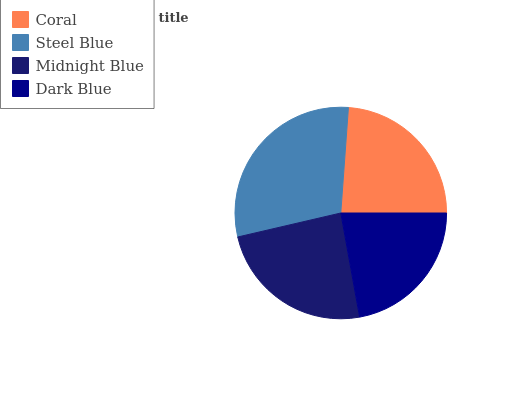Is Dark Blue the minimum?
Answer yes or no. Yes. Is Steel Blue the maximum?
Answer yes or no. Yes. Is Midnight Blue the minimum?
Answer yes or no. No. Is Midnight Blue the maximum?
Answer yes or no. No. Is Steel Blue greater than Midnight Blue?
Answer yes or no. Yes. Is Midnight Blue less than Steel Blue?
Answer yes or no. Yes. Is Midnight Blue greater than Steel Blue?
Answer yes or no. No. Is Steel Blue less than Midnight Blue?
Answer yes or no. No. Is Midnight Blue the high median?
Answer yes or no. Yes. Is Coral the low median?
Answer yes or no. Yes. Is Steel Blue the high median?
Answer yes or no. No. Is Steel Blue the low median?
Answer yes or no. No. 